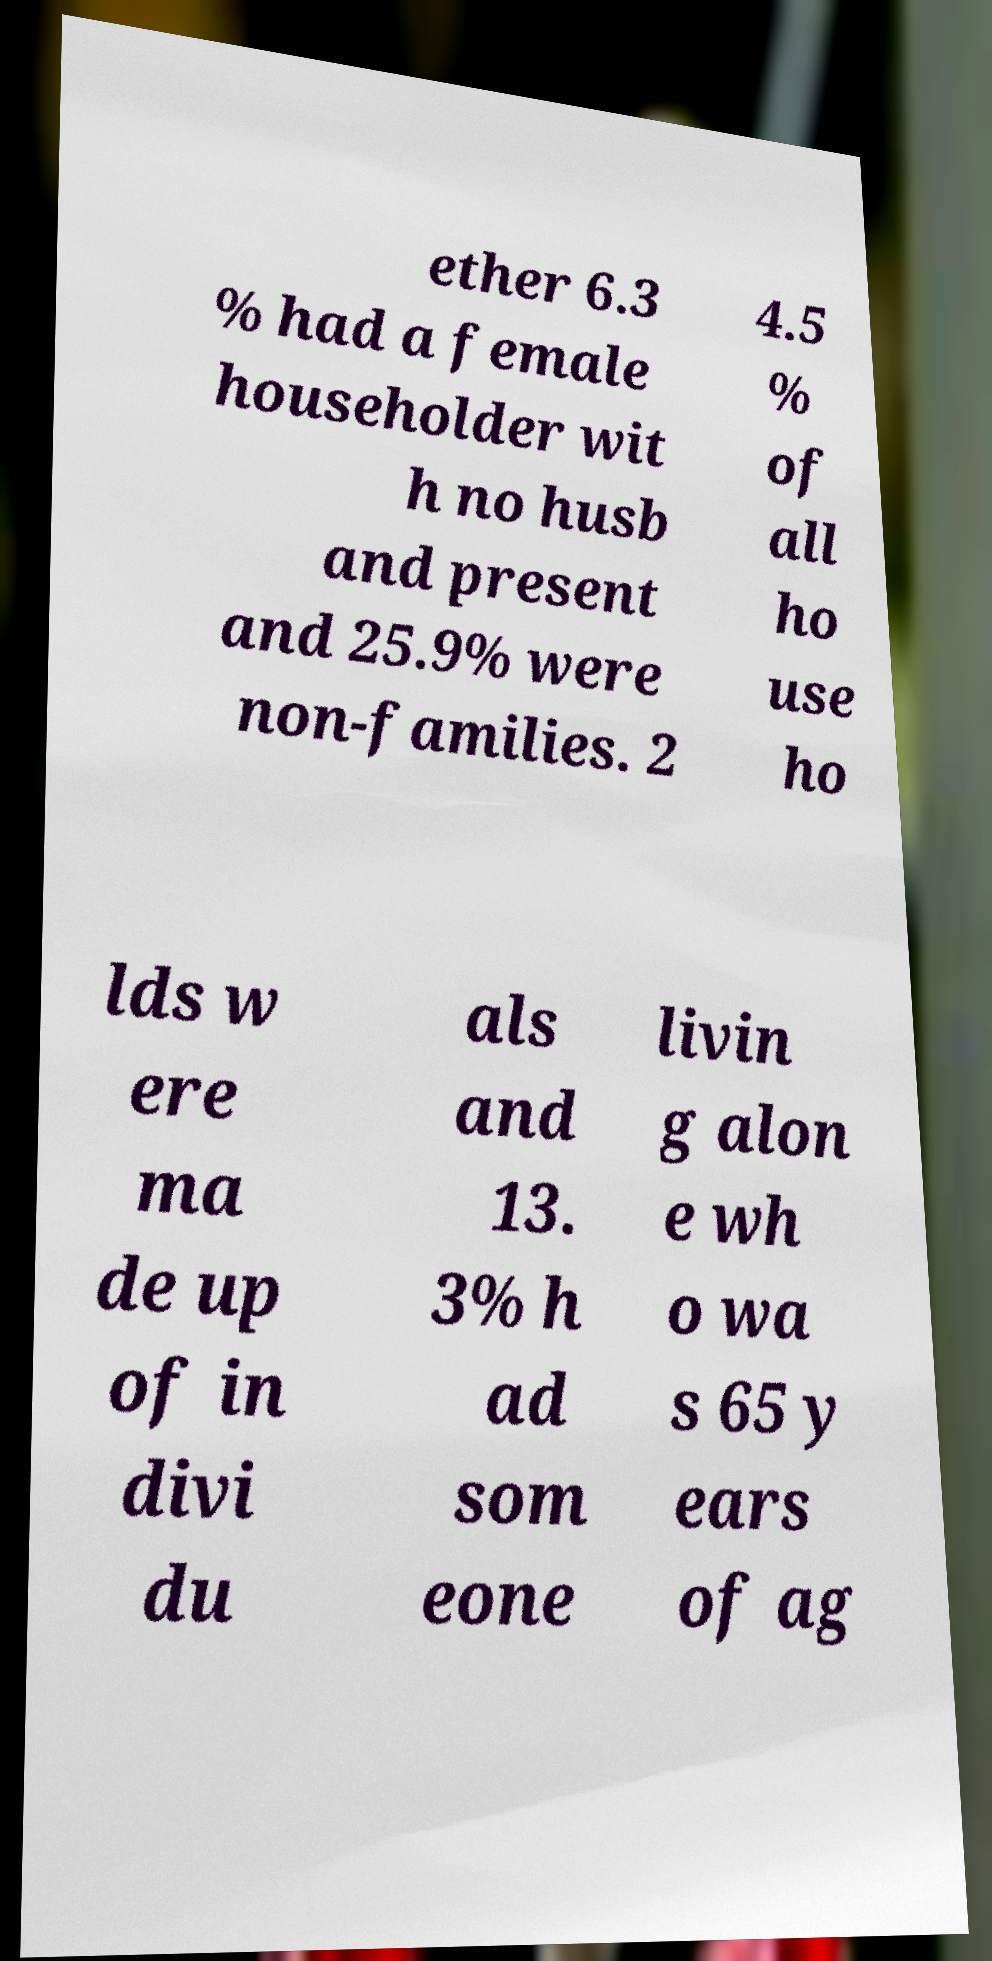What messages or text are displayed in this image? I need them in a readable, typed format. ether 6.3 % had a female householder wit h no husb and present and 25.9% were non-families. 2 4.5 % of all ho use ho lds w ere ma de up of in divi du als and 13. 3% h ad som eone livin g alon e wh o wa s 65 y ears of ag 